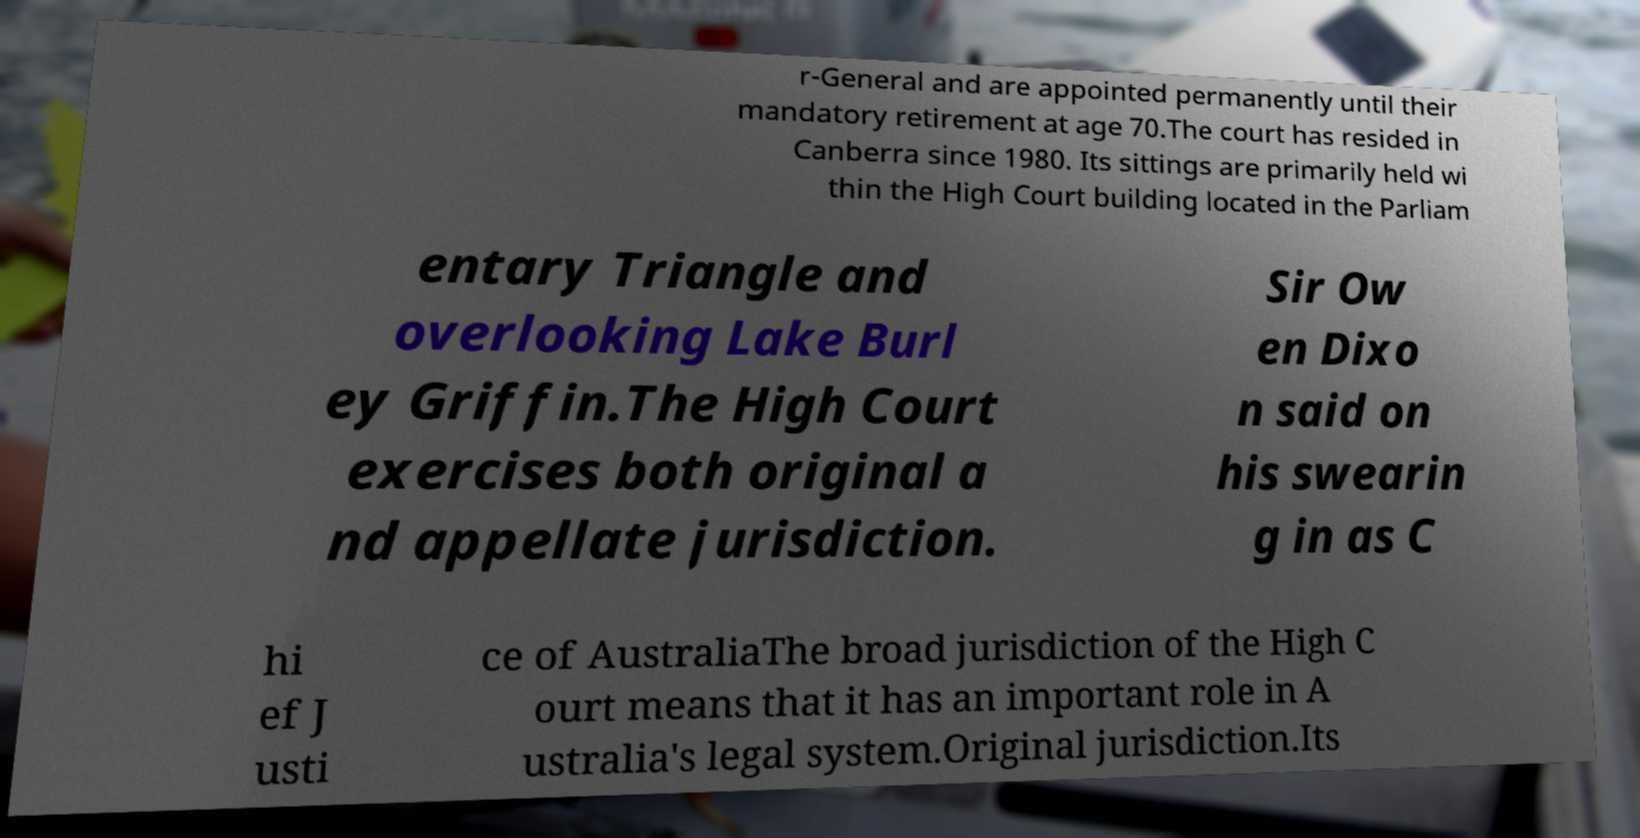For documentation purposes, I need the text within this image transcribed. Could you provide that? r-General and are appointed permanently until their mandatory retirement at age 70.The court has resided in Canberra since 1980. Its sittings are primarily held wi thin the High Court building located in the Parliam entary Triangle and overlooking Lake Burl ey Griffin.The High Court exercises both original a nd appellate jurisdiction. Sir Ow en Dixo n said on his swearin g in as C hi ef J usti ce of AustraliaThe broad jurisdiction of the High C ourt means that it has an important role in A ustralia's legal system.Original jurisdiction.Its 